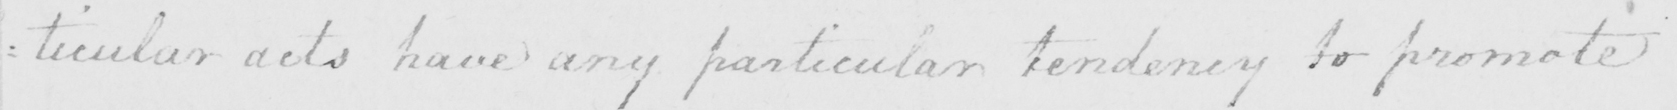Transcribe the text shown in this historical manuscript line. : ticular acts have any particular tendency to promote 